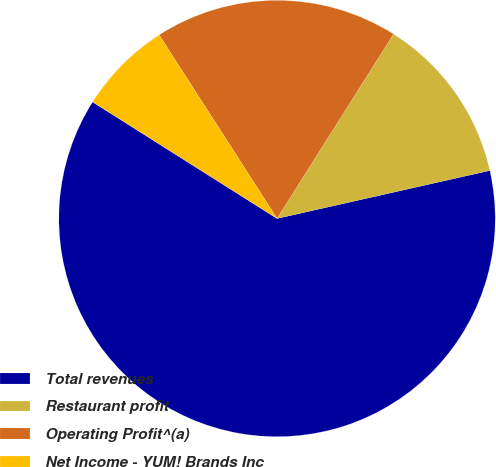<chart> <loc_0><loc_0><loc_500><loc_500><pie_chart><fcel>Total revenues<fcel>Restaurant profit<fcel>Operating Profit^(a)<fcel>Net Income - YUM! Brands Inc<nl><fcel>62.5%<fcel>12.5%<fcel>18.06%<fcel>6.94%<nl></chart> 